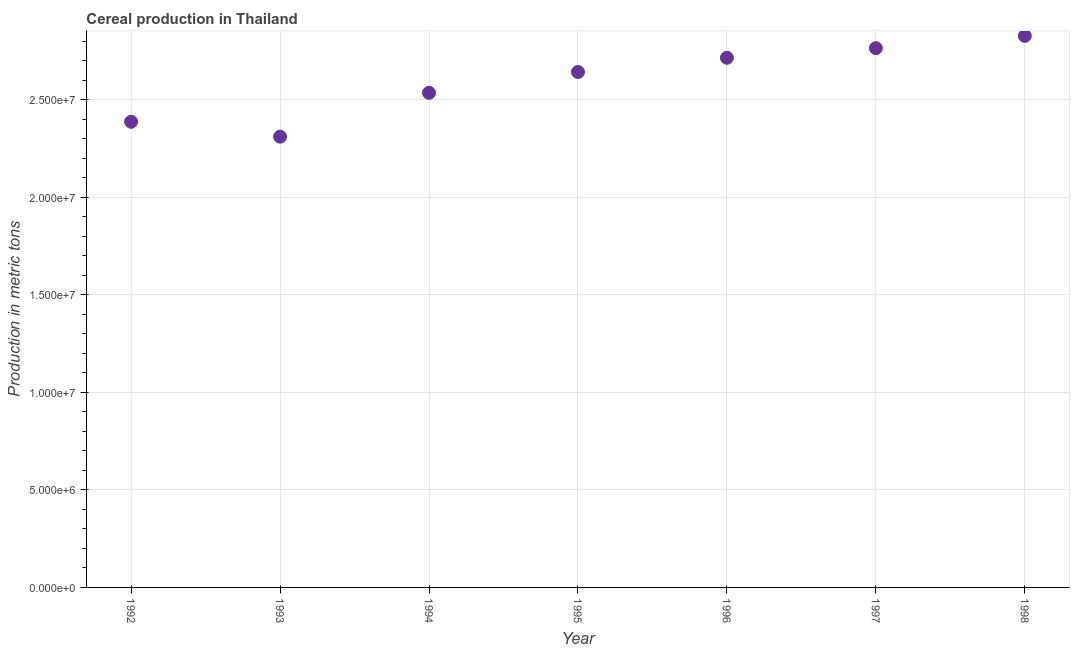What is the cereal production in 1997?
Offer a very short reply. 2.76e+07. Across all years, what is the maximum cereal production?
Keep it short and to the point. 2.83e+07. Across all years, what is the minimum cereal production?
Your answer should be compact. 2.31e+07. In which year was the cereal production maximum?
Keep it short and to the point. 1998. What is the sum of the cereal production?
Your answer should be compact. 1.82e+08. What is the difference between the cereal production in 1993 and 1996?
Provide a succinct answer. -4.04e+06. What is the average cereal production per year?
Your response must be concise. 2.60e+07. What is the median cereal production?
Make the answer very short. 2.64e+07. In how many years, is the cereal production greater than 12000000 metric tons?
Give a very brief answer. 7. Do a majority of the years between 1995 and 1994 (inclusive) have cereal production greater than 2000000 metric tons?
Keep it short and to the point. No. What is the ratio of the cereal production in 1993 to that in 1998?
Your answer should be very brief. 0.82. Is the difference between the cereal production in 1992 and 1997 greater than the difference between any two years?
Provide a succinct answer. No. What is the difference between the highest and the second highest cereal production?
Provide a succinct answer. 6.30e+05. What is the difference between the highest and the lowest cereal production?
Offer a terse response. 5.17e+06. Does the cereal production monotonically increase over the years?
Your answer should be compact. No. How many dotlines are there?
Your answer should be very brief. 1. What is the difference between two consecutive major ticks on the Y-axis?
Provide a short and direct response. 5.00e+06. Are the values on the major ticks of Y-axis written in scientific E-notation?
Give a very brief answer. Yes. What is the title of the graph?
Make the answer very short. Cereal production in Thailand. What is the label or title of the X-axis?
Offer a very short reply. Year. What is the label or title of the Y-axis?
Your answer should be very brief. Production in metric tons. What is the Production in metric tons in 1992?
Your response must be concise. 2.39e+07. What is the Production in metric tons in 1993?
Your answer should be compact. 2.31e+07. What is the Production in metric tons in 1994?
Keep it short and to the point. 2.53e+07. What is the Production in metric tons in 1995?
Your response must be concise. 2.64e+07. What is the Production in metric tons in 1996?
Your response must be concise. 2.71e+07. What is the Production in metric tons in 1997?
Give a very brief answer. 2.76e+07. What is the Production in metric tons in 1998?
Provide a short and direct response. 2.83e+07. What is the difference between the Production in metric tons in 1992 and 1993?
Offer a terse response. 7.64e+05. What is the difference between the Production in metric tons in 1992 and 1994?
Your answer should be very brief. -1.48e+06. What is the difference between the Production in metric tons in 1992 and 1995?
Provide a short and direct response. -2.55e+06. What is the difference between the Production in metric tons in 1992 and 1996?
Your answer should be very brief. -3.28e+06. What is the difference between the Production in metric tons in 1992 and 1997?
Your answer should be compact. -3.77e+06. What is the difference between the Production in metric tons in 1992 and 1998?
Your response must be concise. -4.40e+06. What is the difference between the Production in metric tons in 1993 and 1994?
Keep it short and to the point. -2.25e+06. What is the difference between the Production in metric tons in 1993 and 1995?
Keep it short and to the point. -3.31e+06. What is the difference between the Production in metric tons in 1993 and 1996?
Offer a very short reply. -4.04e+06. What is the difference between the Production in metric tons in 1993 and 1997?
Your answer should be compact. -4.54e+06. What is the difference between the Production in metric tons in 1993 and 1998?
Your response must be concise. -5.17e+06. What is the difference between the Production in metric tons in 1994 and 1995?
Give a very brief answer. -1.07e+06. What is the difference between the Production in metric tons in 1994 and 1996?
Provide a succinct answer. -1.80e+06. What is the difference between the Production in metric tons in 1994 and 1997?
Offer a terse response. -2.29e+06. What is the difference between the Production in metric tons in 1994 and 1998?
Keep it short and to the point. -2.92e+06. What is the difference between the Production in metric tons in 1995 and 1996?
Ensure brevity in your answer.  -7.29e+05. What is the difference between the Production in metric tons in 1995 and 1997?
Provide a succinct answer. -1.22e+06. What is the difference between the Production in metric tons in 1995 and 1998?
Offer a terse response. -1.85e+06. What is the difference between the Production in metric tons in 1996 and 1997?
Your response must be concise. -4.92e+05. What is the difference between the Production in metric tons in 1996 and 1998?
Provide a succinct answer. -1.12e+06. What is the difference between the Production in metric tons in 1997 and 1998?
Your answer should be compact. -6.30e+05. What is the ratio of the Production in metric tons in 1992 to that in 1993?
Provide a succinct answer. 1.03. What is the ratio of the Production in metric tons in 1992 to that in 1994?
Give a very brief answer. 0.94. What is the ratio of the Production in metric tons in 1992 to that in 1995?
Your response must be concise. 0.9. What is the ratio of the Production in metric tons in 1992 to that in 1996?
Offer a very short reply. 0.88. What is the ratio of the Production in metric tons in 1992 to that in 1997?
Provide a short and direct response. 0.86. What is the ratio of the Production in metric tons in 1992 to that in 1998?
Your response must be concise. 0.84. What is the ratio of the Production in metric tons in 1993 to that in 1994?
Provide a short and direct response. 0.91. What is the ratio of the Production in metric tons in 1993 to that in 1995?
Provide a short and direct response. 0.88. What is the ratio of the Production in metric tons in 1993 to that in 1996?
Ensure brevity in your answer.  0.85. What is the ratio of the Production in metric tons in 1993 to that in 1997?
Make the answer very short. 0.84. What is the ratio of the Production in metric tons in 1993 to that in 1998?
Your response must be concise. 0.82. What is the ratio of the Production in metric tons in 1994 to that in 1995?
Provide a succinct answer. 0.96. What is the ratio of the Production in metric tons in 1994 to that in 1996?
Offer a very short reply. 0.93. What is the ratio of the Production in metric tons in 1994 to that in 1997?
Your response must be concise. 0.92. What is the ratio of the Production in metric tons in 1994 to that in 1998?
Ensure brevity in your answer.  0.9. What is the ratio of the Production in metric tons in 1995 to that in 1996?
Make the answer very short. 0.97. What is the ratio of the Production in metric tons in 1995 to that in 1997?
Give a very brief answer. 0.96. What is the ratio of the Production in metric tons in 1995 to that in 1998?
Your response must be concise. 0.94. 